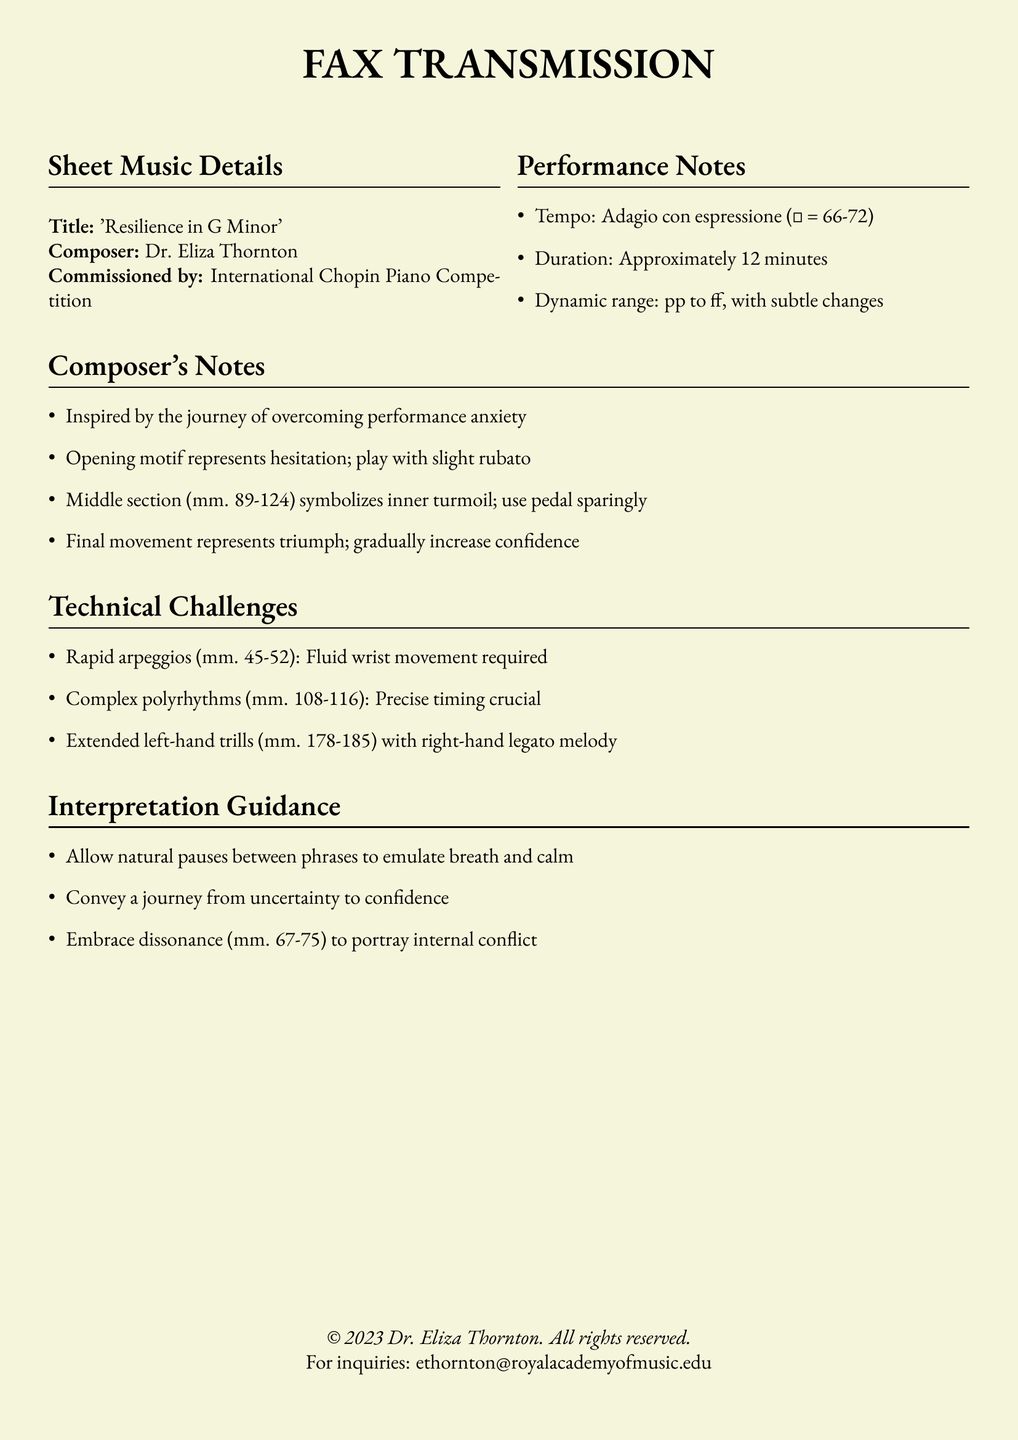what is the title of the piece? The title is prominently mentioned at the top of the document.
Answer: 'Resilience in G Minor' who is the composer? The composer's name is listed in the details section.
Answer: Dr. Eliza Thornton what is the tempo for the piece? The tempo is specified in the performance notes.
Answer: Adagio con espressione (♩ = 66-72) how long is the duration of the piece? The duration is provided in the performance notes as an approximate time.
Answer: Approximately 12 minutes what dynamic range is noted for the performance? The dynamic range is included in the performance notes.
Answer: pp to ff, with subtle changes what does the opening motif represent according to the composer? The composer notes that the opening motif conveys a specific theme.
Answer: Hesitation which section symbolizes inner turmoil? The composer indicates a specific range of measures for this section.
Answer: Middle section (mm. 89-124) what should be embraced to portray internal conflict? The composer gives guidance regarding a musical technique.
Answer: Dissonance (mm. 67-75) which technical challenge involves rapid arpeggios? This specific challenge is detailed under the technical challenges section.
Answer: mm. 45-52 what is the email address for inquiries? The contact information is provided at the bottom of the document.
Answer: ethornton@royalacademyofmusic.edu 